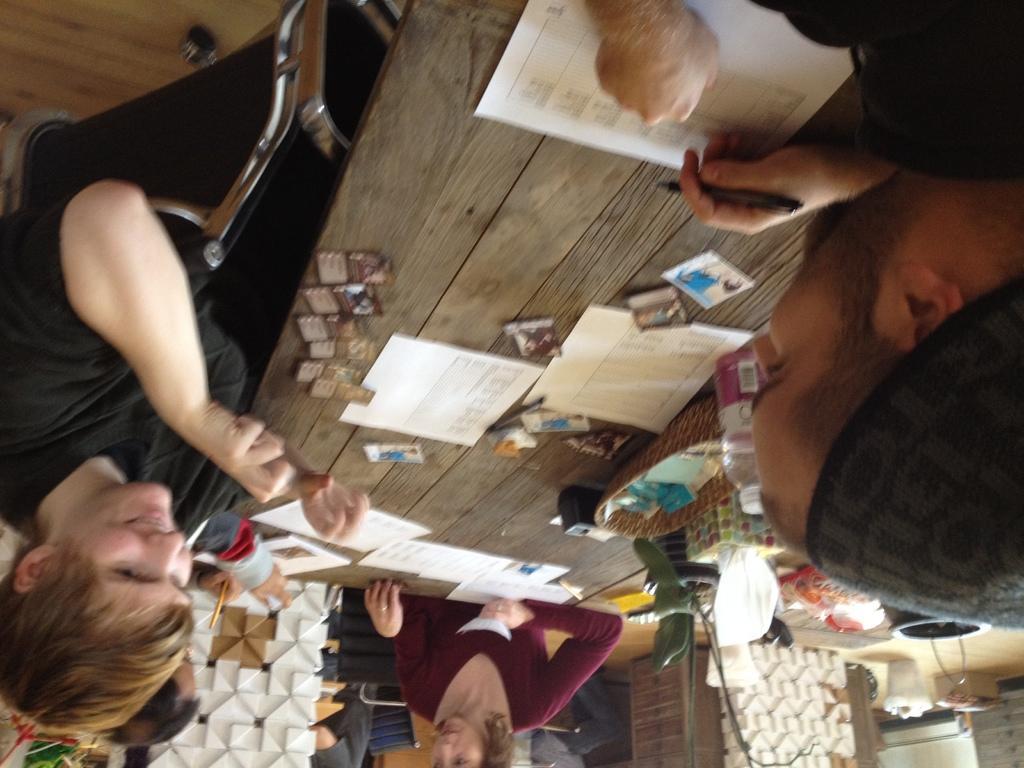Can you describe this image briefly? In this image we can see few persons sitting on the chairs. There are few objects on the table. At the bottom we can see a white object, houseplant, dustbin and wooden table. 